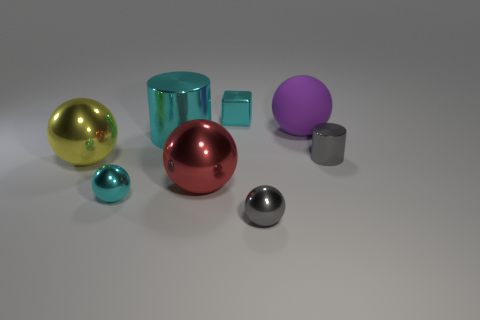Subtract all tiny gray metallic spheres. How many spheres are left? 4 Subtract all purple balls. How many balls are left? 4 Add 2 cyan spheres. How many objects exist? 10 Subtract all purple balls. Subtract all cyan cylinders. How many balls are left? 4 Subtract all blocks. How many objects are left? 7 Subtract all small green spheres. Subtract all big purple rubber balls. How many objects are left? 7 Add 3 blocks. How many blocks are left? 4 Add 2 gray shiny cylinders. How many gray shiny cylinders exist? 3 Subtract 0 red cylinders. How many objects are left? 8 